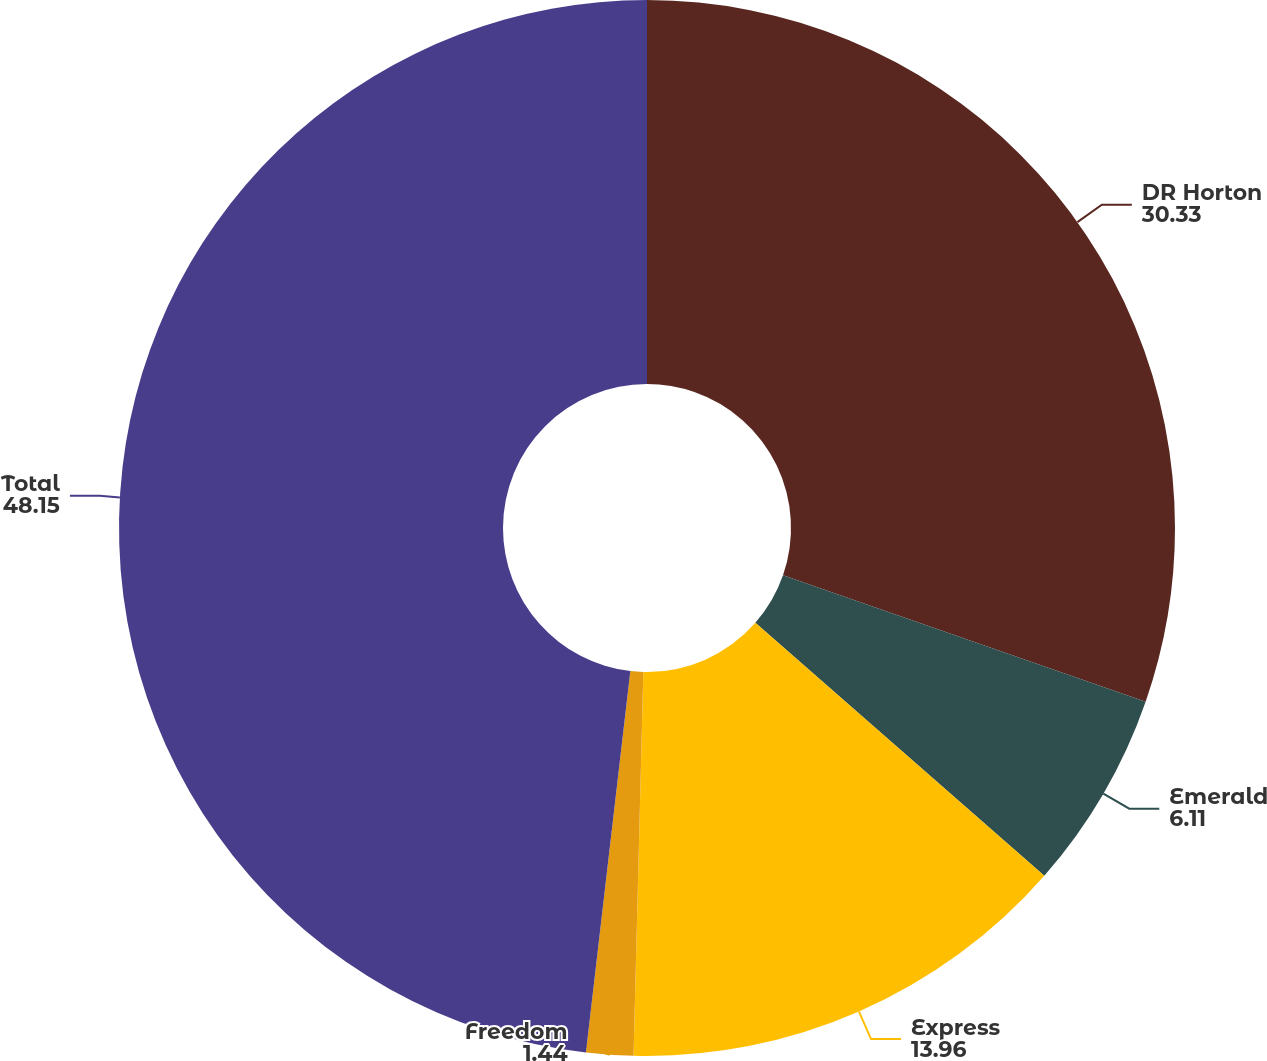<chart> <loc_0><loc_0><loc_500><loc_500><pie_chart><fcel>DR Horton<fcel>Emerald<fcel>Express<fcel>Freedom<fcel>Total<nl><fcel>30.33%<fcel>6.11%<fcel>13.96%<fcel>1.44%<fcel>48.15%<nl></chart> 